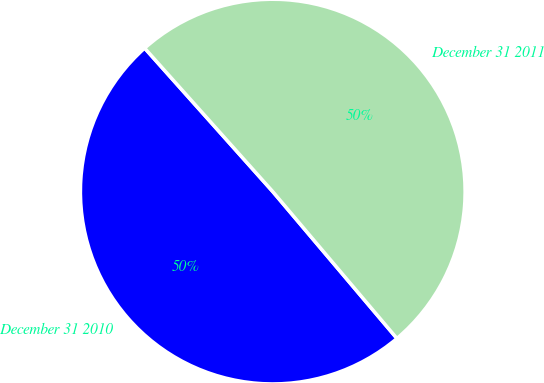Convert chart. <chart><loc_0><loc_0><loc_500><loc_500><pie_chart><fcel>December 31 2010<fcel>December 31 2011<nl><fcel>49.57%<fcel>50.43%<nl></chart> 